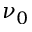<formula> <loc_0><loc_0><loc_500><loc_500>\nu _ { 0 }</formula> 